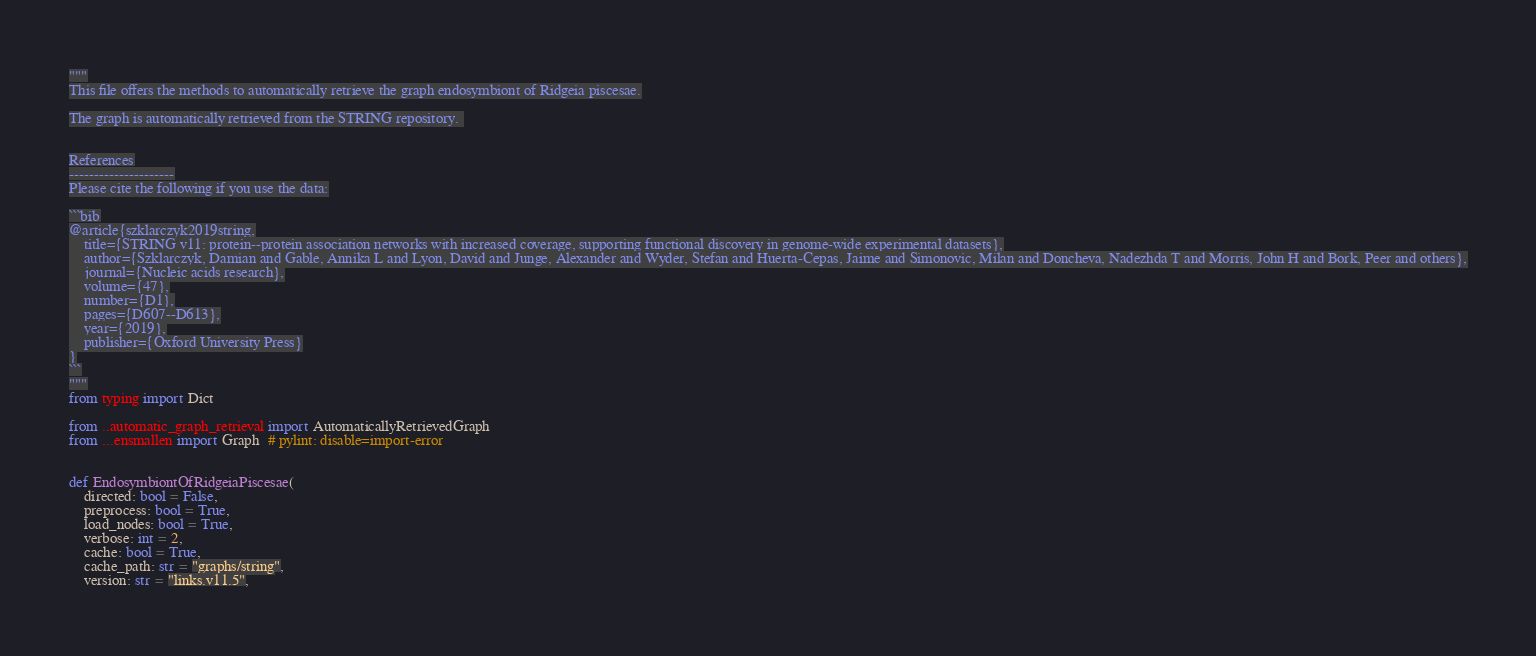Convert code to text. <code><loc_0><loc_0><loc_500><loc_500><_Python_>"""
This file offers the methods to automatically retrieve the graph endosymbiont of Ridgeia piscesae.

The graph is automatically retrieved from the STRING repository. 


References
---------------------
Please cite the following if you use the data:

```bib
@article{szklarczyk2019string,
    title={STRING v11: protein--protein association networks with increased coverage, supporting functional discovery in genome-wide experimental datasets},
    author={Szklarczyk, Damian and Gable, Annika L and Lyon, David and Junge, Alexander and Wyder, Stefan and Huerta-Cepas, Jaime and Simonovic, Milan and Doncheva, Nadezhda T and Morris, John H and Bork, Peer and others},
    journal={Nucleic acids research},
    volume={47},
    number={D1},
    pages={D607--D613},
    year={2019},
    publisher={Oxford University Press}
}
```
"""
from typing import Dict

from ..automatic_graph_retrieval import AutomaticallyRetrievedGraph
from ...ensmallen import Graph  # pylint: disable=import-error


def EndosymbiontOfRidgeiaPiscesae(
    directed: bool = False,
    preprocess: bool = True,
    load_nodes: bool = True,
    verbose: int = 2,
    cache: bool = True,
    cache_path: str = "graphs/string",
    version: str = "links.v11.5",</code> 